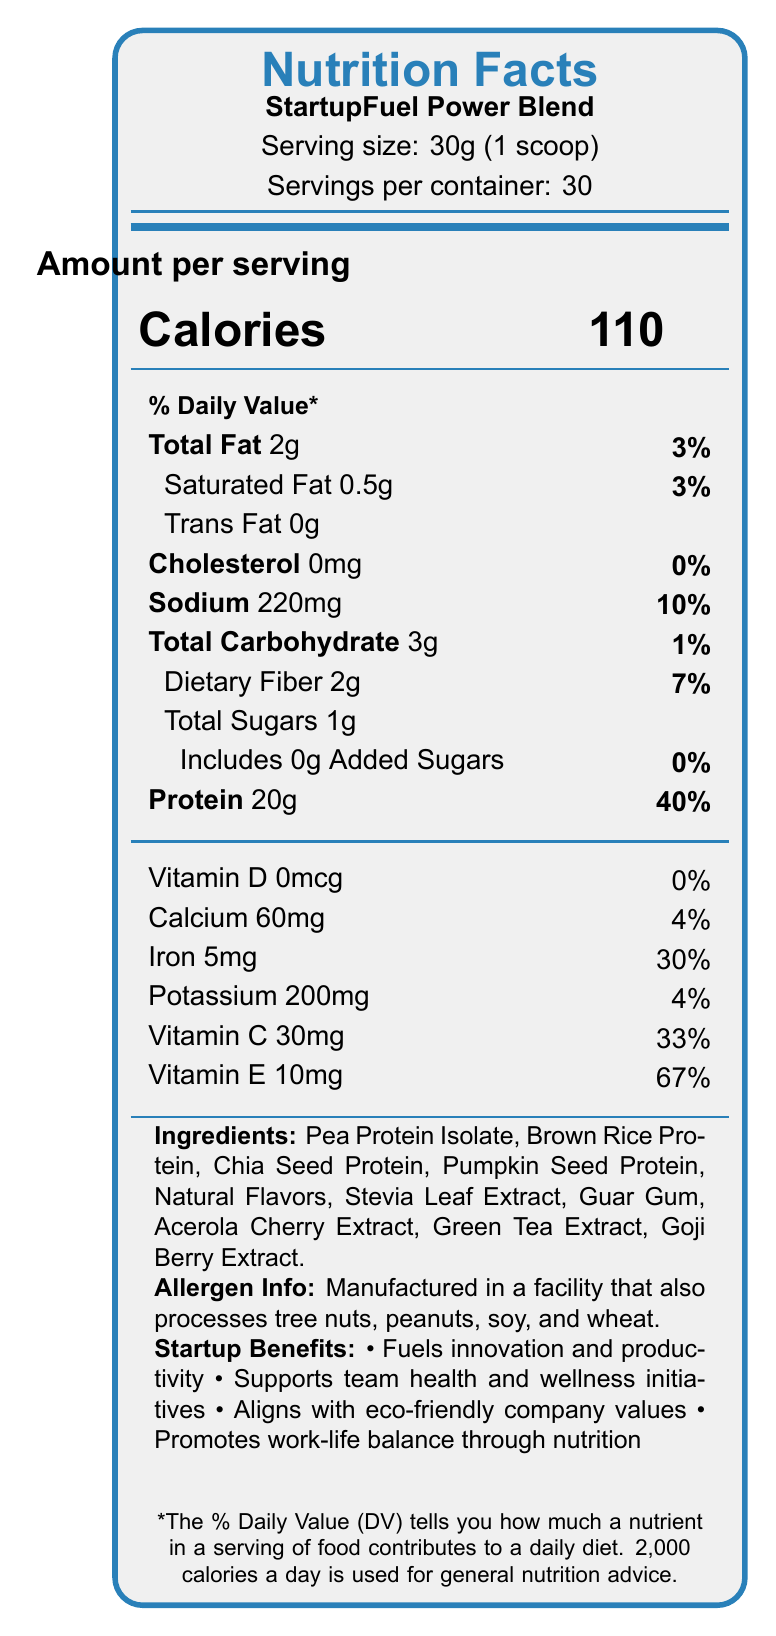how many calories are in one serving? The document states that the amount per serving is 110 calories.
Answer: 110 what is the serving size of the product? The document indicates the serving size as 30g (1 scoop).
Answer: 30g (1 scoop) how much dietary fiber is in one serving? The document lists 2g of dietary fiber per serving.
Answer: 2g what is the total amount of protein per serving? According to the document, each serving contains 20g of protein.
Answer: 20g what are the ingredients listed in this product? The ingredients are provided under the "Ingredients" section in the document.
Answer: Pea Protein Isolate, Brown Rice Protein, Chia Seed Protein, Pumpkin Seed Protein, Natural Flavors, Stevia Leaf Extract, Guar Gum, Acerola Cherry Extract, Green Tea Extract, Goji Berry Extract which vitamin provides the highest percentage of daily value (DV) per serving? A. Vitamin D B. Calcium C. Iron D. Vitamin E Vitamin E provides 67% of the daily value, which is the highest among the listed vitamins.
Answer: D which of the following is not an ingredient in the product? A. Whey Protein B. Pea Protein Isolate C. Chia Seed Protein D. Guar Gum Whey Protein is not listed in the ingredients; the correct options of ingredients are Pea Protein Isolate, Chia Seed Protein, and Guar Gum.
Answer: A is the product free of cholesterol? The document states that the product contains 0mg of cholesterol, meaning it is cholesterol-free.
Answer: Yes what are the key health claims made by the product? These health claims are explicitly listed in the document.
Answer: Excellent source of plant-based protein, Rich in antioxidants, Supports cognitive function and productivity, Promotes sustainable energy for long coding sessions how much sodium is in each serving? The sodium content per serving is listed as 220mg in the document.
Answer: 220mg which added benefits does this product claim to support for startup teams? These benefits are outlined under the "Startup Benefits" section in the document.
Answer: Fuels innovation and productivity, Supports team health and wellness initiatives, Aligns with eco-friendly company values, Promotes work-life balance through nutrition what percentage of the daily value of calcium does one serving provide? The document mentions that each serving contains 4% of the daily value of calcium.
Answer: 4% how many servings are there per container? The document states that each container provides 30 servings.
Answer: 30 what is the purpose of the product based on its intended demographic (startup teams)? These benefits are particularly tailored to the needs and values of startup teams, as described in the "Startup Benefits" section.
Answer: The product is designed to fuel innovation and productivity, support team health and wellness initiatives, align with eco-friendly company values, and promote work-life balance through nutrition. does the product contain any added sugars? The document states that the product contains 0g added sugars, indicating no added sugars.
Answer: No what are the possible allergens mentioned for the product? The document specifies that the product is manufactured in a facility that also processes tree nuts, peanuts, soy, and wheat.
Answer: Tree nuts, peanuts, soy, wheat is this product suitable for a vegan diet? The document does not explicitly state if the product is suitable for a vegan diet, though it lists plant-based proteins; however, full suitability is not confirmed without additional information.
Answer: Cannot be determined 